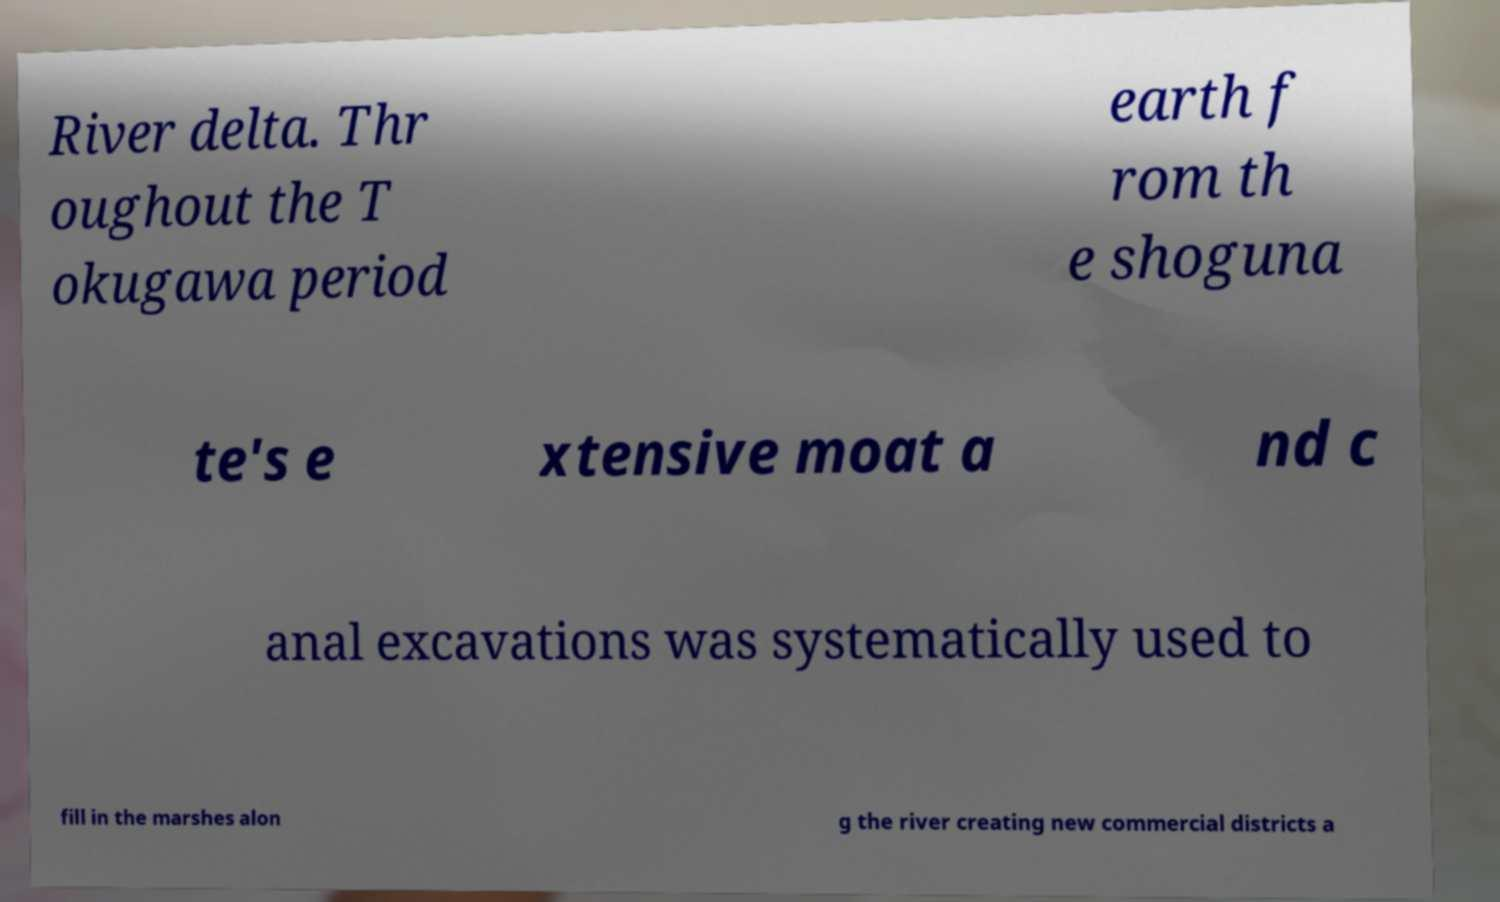Could you assist in decoding the text presented in this image and type it out clearly? River delta. Thr oughout the T okugawa period earth f rom th e shoguna te's e xtensive moat a nd c anal excavations was systematically used to fill in the marshes alon g the river creating new commercial districts a 